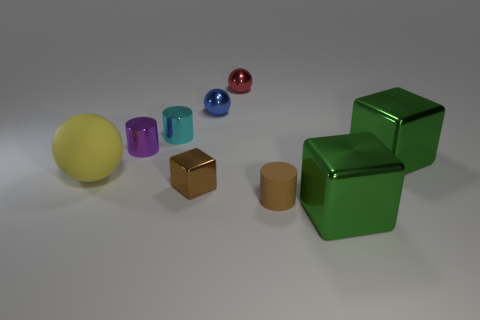What size is the red ball that is made of the same material as the small cube?
Ensure brevity in your answer.  Small. What is the size of the green block that is to the right of the green metallic cube that is in front of the big green block behind the brown rubber cylinder?
Your response must be concise. Large. There is a blue shiny thing that is on the right side of the tiny purple cylinder; what is its size?
Keep it short and to the point. Small. What number of gray things are matte cylinders or small cubes?
Your answer should be very brief. 0. Is there a block of the same size as the yellow ball?
Your answer should be compact. Yes. There is a blue object that is the same size as the brown cube; what is its material?
Your response must be concise. Metal. There is a cylinder that is on the right side of the tiny cyan object; is it the same size as the green metallic object behind the tiny brown metallic cube?
Offer a very short reply. No. What number of objects are either blue shiny balls or large things that are left of the cyan shiny cylinder?
Make the answer very short. 2. Are there any blue objects of the same shape as the cyan object?
Provide a short and direct response. No. There is a blue metal thing on the right side of the matte thing that is left of the red ball; what is its size?
Make the answer very short. Small. 